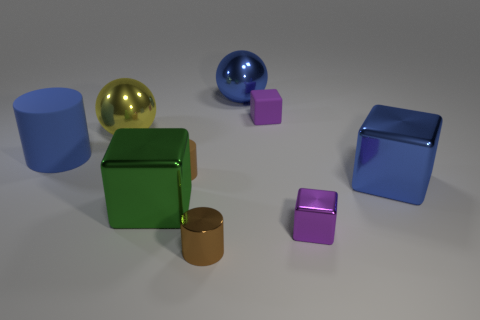Subtract all large blue cubes. How many cubes are left? 3 Subtract 1 cubes. How many cubes are left? 3 Subtract all blue spheres. How many spheres are left? 1 Subtract all cylinders. How many objects are left? 6 Subtract all red cylinders. Subtract all blue spheres. How many cylinders are left? 3 Subtract all blue blocks. How many yellow spheres are left? 1 Subtract all purple metal cylinders. Subtract all large blue cubes. How many objects are left? 8 Add 3 tiny purple metallic blocks. How many tiny purple metallic blocks are left? 4 Add 9 large purple blocks. How many large purple blocks exist? 9 Subtract 0 red blocks. How many objects are left? 9 